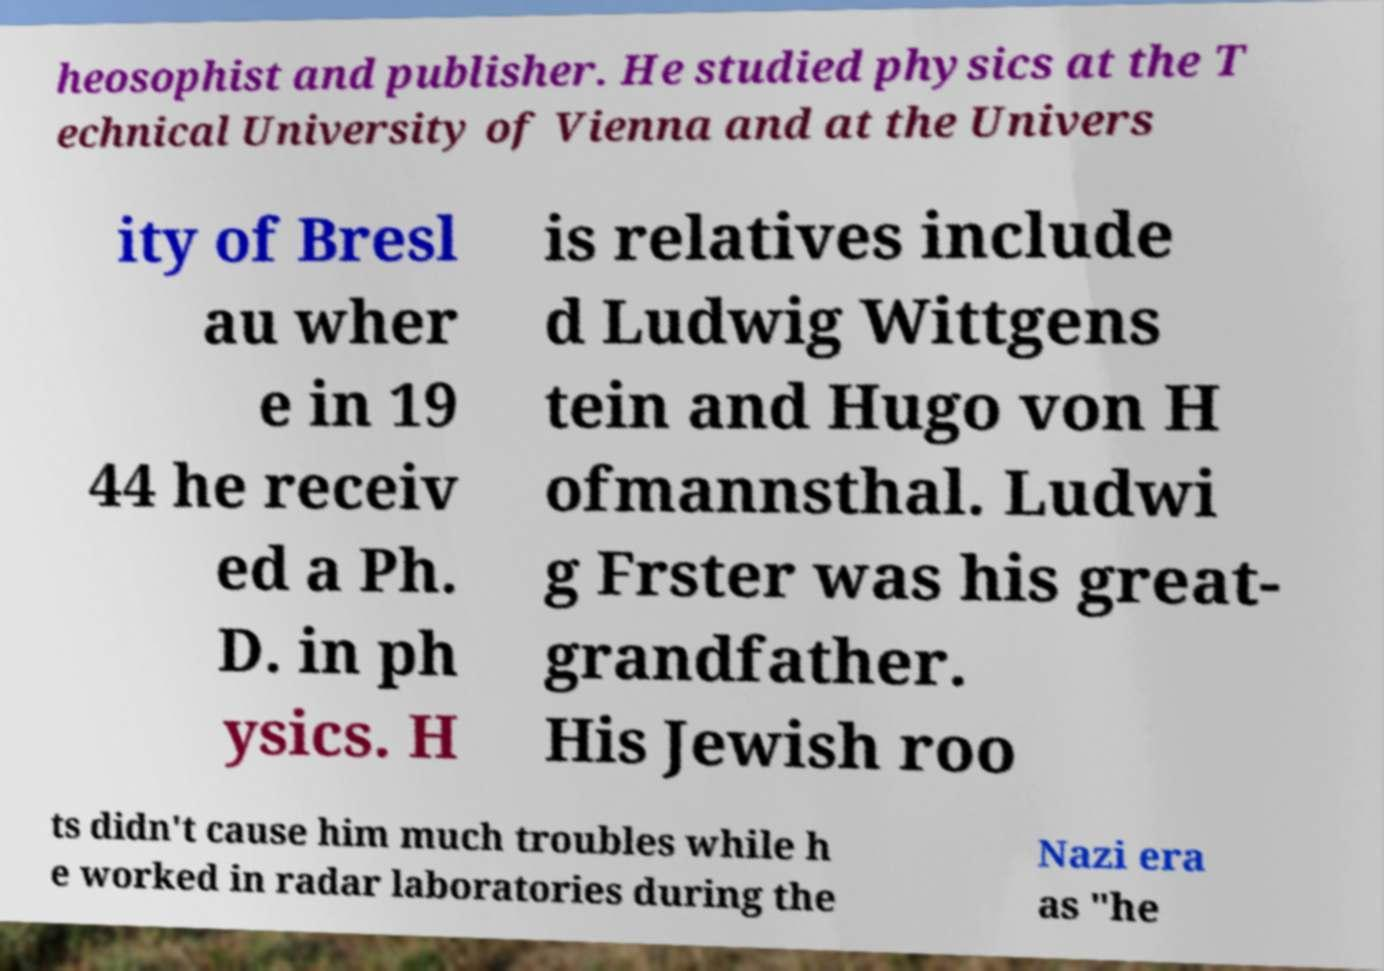Can you accurately transcribe the text from the provided image for me? heosophist and publisher. He studied physics at the T echnical University of Vienna and at the Univers ity of Bresl au wher e in 19 44 he receiv ed a Ph. D. in ph ysics. H is relatives include d Ludwig Wittgens tein and Hugo von H ofmannsthal. Ludwi g Frster was his great- grandfather. His Jewish roo ts didn't cause him much troubles while h e worked in radar laboratories during the Nazi era as "he 